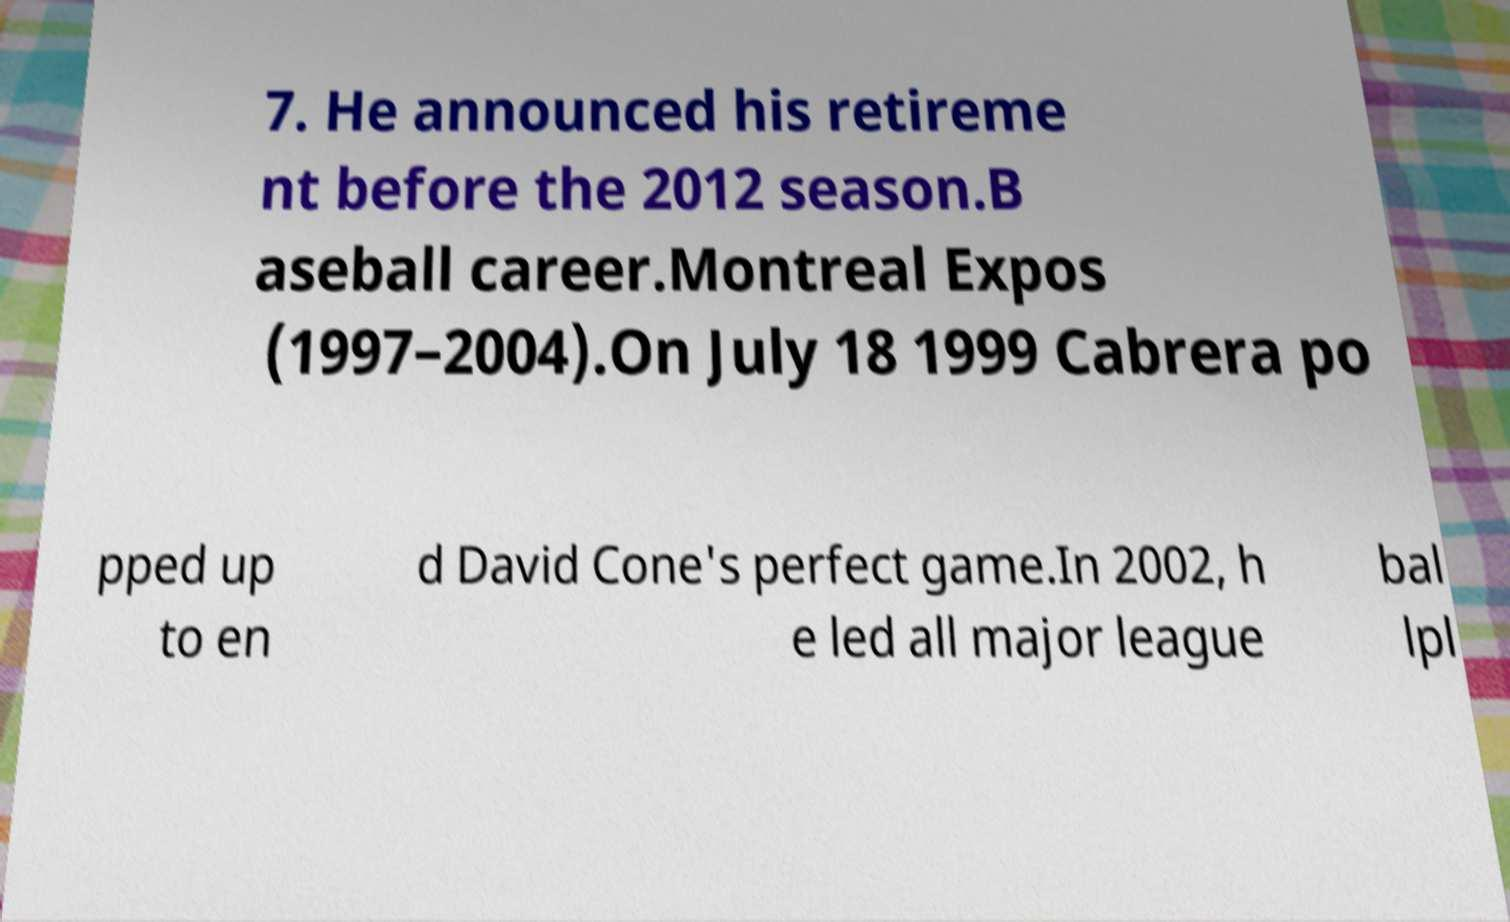There's text embedded in this image that I need extracted. Can you transcribe it verbatim? 7. He announced his retireme nt before the 2012 season.B aseball career.Montreal Expos (1997–2004).On July 18 1999 Cabrera po pped up to en d David Cone's perfect game.In 2002, h e led all major league bal lpl 